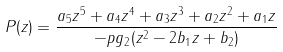<formula> <loc_0><loc_0><loc_500><loc_500>P ( z ) = \frac { { a _ { 5 } } { z ^ { 5 } } + { a _ { 4 } } { z ^ { 4 } } + { a _ { 3 } } { z ^ { 3 } } + { a _ { 2 } } { z ^ { 2 } } + { a _ { 1 } } z } { - p g _ { 2 } ( { z ^ { 2 } } - { 2 b _ { 1 } } { z } + { b _ { 2 } } ) }</formula> 